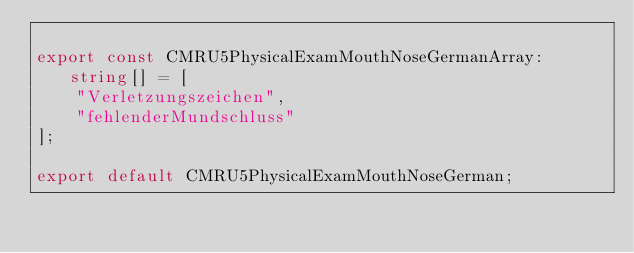Convert code to text. <code><loc_0><loc_0><loc_500><loc_500><_TypeScript_>
export const CMRU5PhysicalExamMouthNoseGermanArray: string[] = [
    "Verletzungszeichen",
    "fehlenderMundschluss"
];

export default CMRU5PhysicalExamMouthNoseGerman;
</code> 